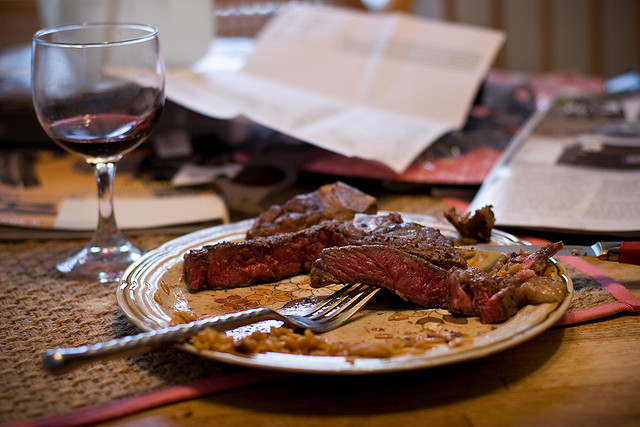<image>What clear liquid is in the glass? I am not sure what the clear liquid in the glass is. However, it might be wine. What clear liquid is in the glass? The clear liquid in the glass is wine. 